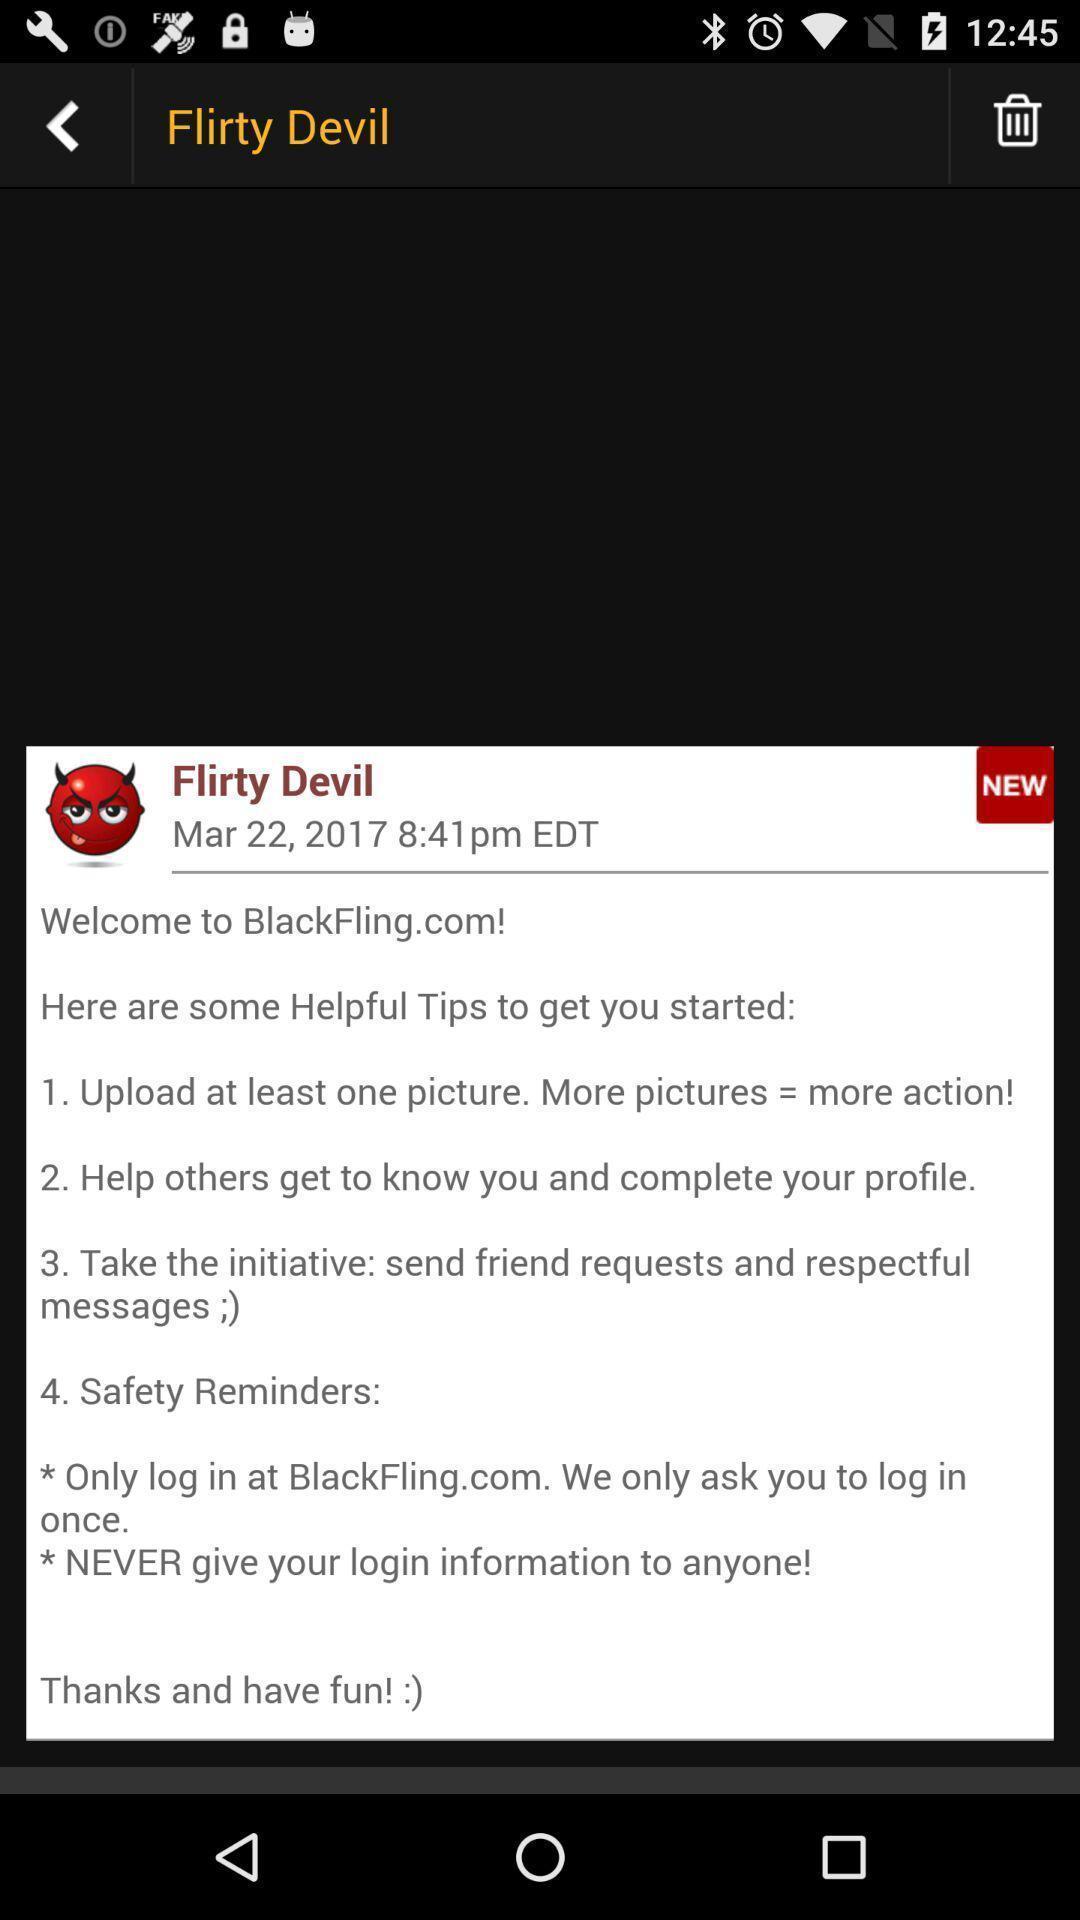Describe the visual elements of this screenshot. Profile and tips list of social app. 